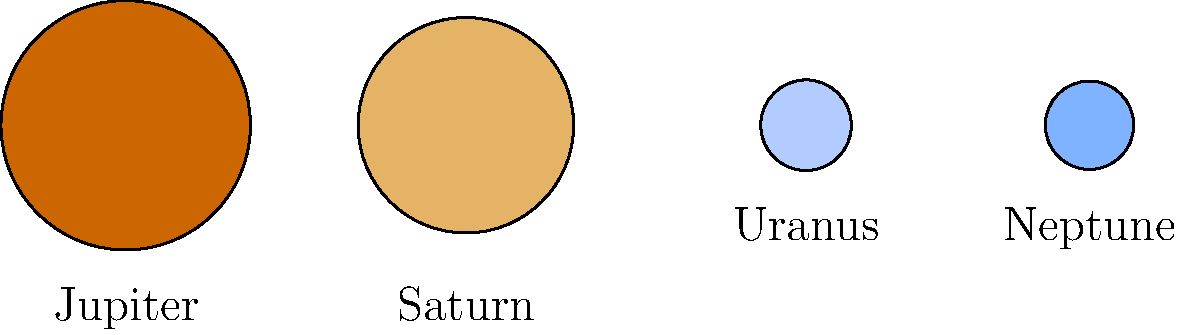In this scaled representation of some of our solar system's gas giants, which planet is depicted as the largest? To determine which planet is depicted as the largest in this scaled representation, we need to compare the sizes of the circles representing each planet:

1. Jupiter is represented by the leftmost circle, which appears to be the largest.
2. Saturn is the second from the left, slightly smaller than Jupiter.
3. Uranus and Neptune are represented by the two smallest circles on the right.

The relative sizes in this representation reflect the actual size differences between these gas giants in our solar system:

1. Jupiter is the largest planet in our solar system, with a radius of about 69,911 km.
2. Saturn is the second-largest, with a radius of about 58,232 km.
3. Uranus and Neptune are similar in size, with radii of about 25,362 km and 24,622 km, respectively.

Based on this information and the visual representation, we can conclude that Jupiter is depicted as the largest planet in this scaled image.
Answer: Jupiter 